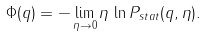Convert formula to latex. <formula><loc_0><loc_0><loc_500><loc_500>\Phi ( q ) = - \lim _ { \eta \rightarrow 0 } \eta \, \ln P _ { s t a t } ( q , \eta ) .</formula> 